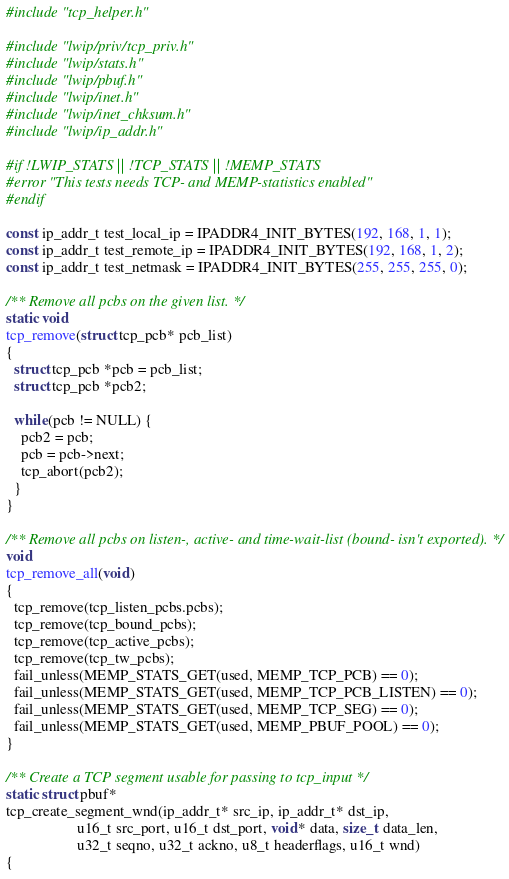<code> <loc_0><loc_0><loc_500><loc_500><_C_>#include "tcp_helper.h"

#include "lwip/priv/tcp_priv.h"
#include "lwip/stats.h"
#include "lwip/pbuf.h"
#include "lwip/inet.h"
#include "lwip/inet_chksum.h"
#include "lwip/ip_addr.h"

#if !LWIP_STATS || !TCP_STATS || !MEMP_STATS
#error "This tests needs TCP- and MEMP-statistics enabled"
#endif

const ip_addr_t test_local_ip = IPADDR4_INIT_BYTES(192, 168, 1, 1);
const ip_addr_t test_remote_ip = IPADDR4_INIT_BYTES(192, 168, 1, 2);
const ip_addr_t test_netmask = IPADDR4_INIT_BYTES(255, 255, 255, 0);

/** Remove all pcbs on the given list. */
static void
tcp_remove(struct tcp_pcb* pcb_list)
{
  struct tcp_pcb *pcb = pcb_list;
  struct tcp_pcb *pcb2;

  while(pcb != NULL) {
    pcb2 = pcb;
    pcb = pcb->next;
    tcp_abort(pcb2);
  }
}

/** Remove all pcbs on listen-, active- and time-wait-list (bound- isn't exported). */
void
tcp_remove_all(void)
{
  tcp_remove(tcp_listen_pcbs.pcbs);
  tcp_remove(tcp_bound_pcbs);
  tcp_remove(tcp_active_pcbs);
  tcp_remove(tcp_tw_pcbs);
  fail_unless(MEMP_STATS_GET(used, MEMP_TCP_PCB) == 0);
  fail_unless(MEMP_STATS_GET(used, MEMP_TCP_PCB_LISTEN) == 0);
  fail_unless(MEMP_STATS_GET(used, MEMP_TCP_SEG) == 0);
  fail_unless(MEMP_STATS_GET(used, MEMP_PBUF_POOL) == 0);
}

/** Create a TCP segment usable for passing to tcp_input */
static struct pbuf*
tcp_create_segment_wnd(ip_addr_t* src_ip, ip_addr_t* dst_ip,
                   u16_t src_port, u16_t dst_port, void* data, size_t data_len,
                   u32_t seqno, u32_t ackno, u8_t headerflags, u16_t wnd)
{</code> 